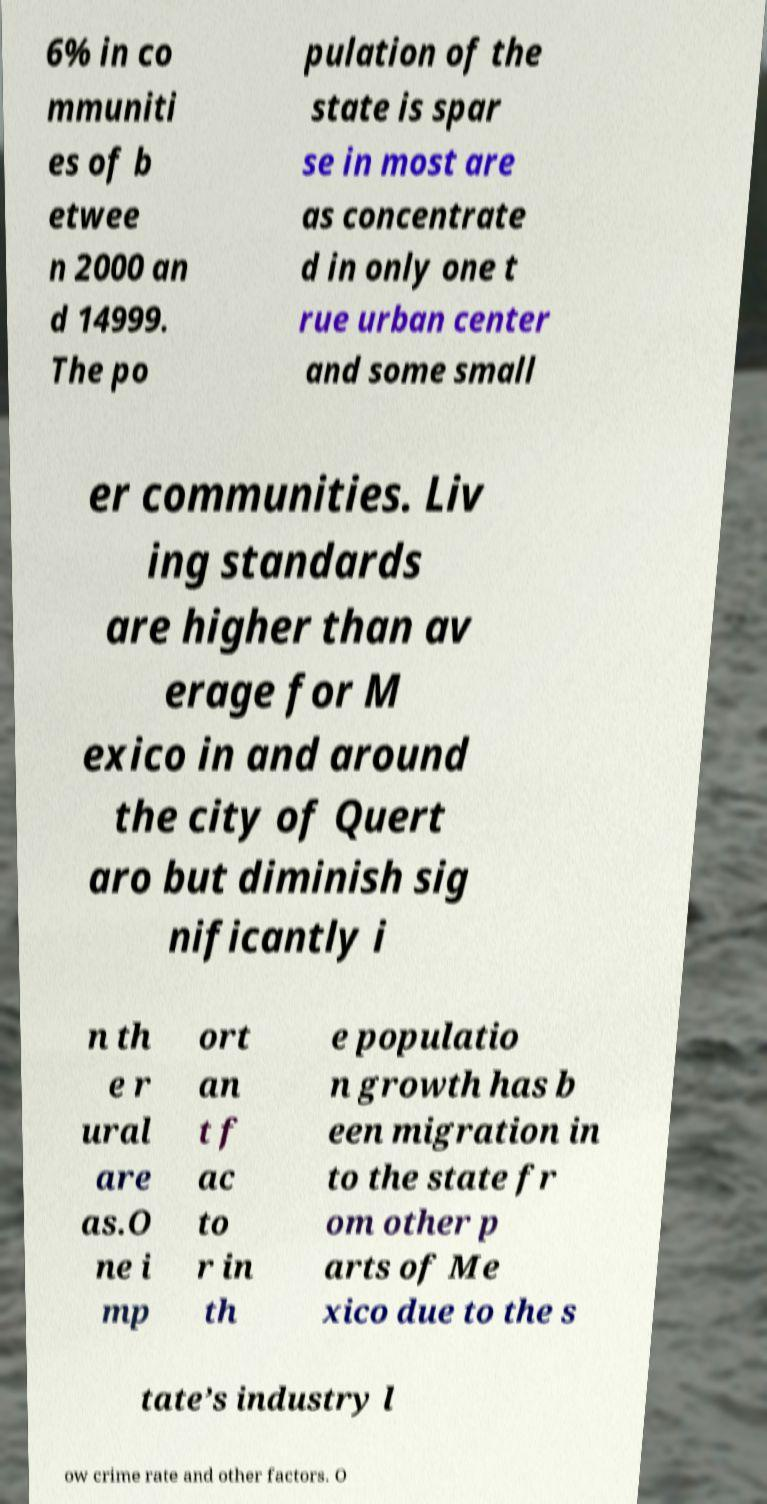Can you read and provide the text displayed in the image?This photo seems to have some interesting text. Can you extract and type it out for me? 6% in co mmuniti es of b etwee n 2000 an d 14999. The po pulation of the state is spar se in most are as concentrate d in only one t rue urban center and some small er communities. Liv ing standards are higher than av erage for M exico in and around the city of Quert aro but diminish sig nificantly i n th e r ural are as.O ne i mp ort an t f ac to r in th e populatio n growth has b een migration in to the state fr om other p arts of Me xico due to the s tate’s industry l ow crime rate and other factors. O 